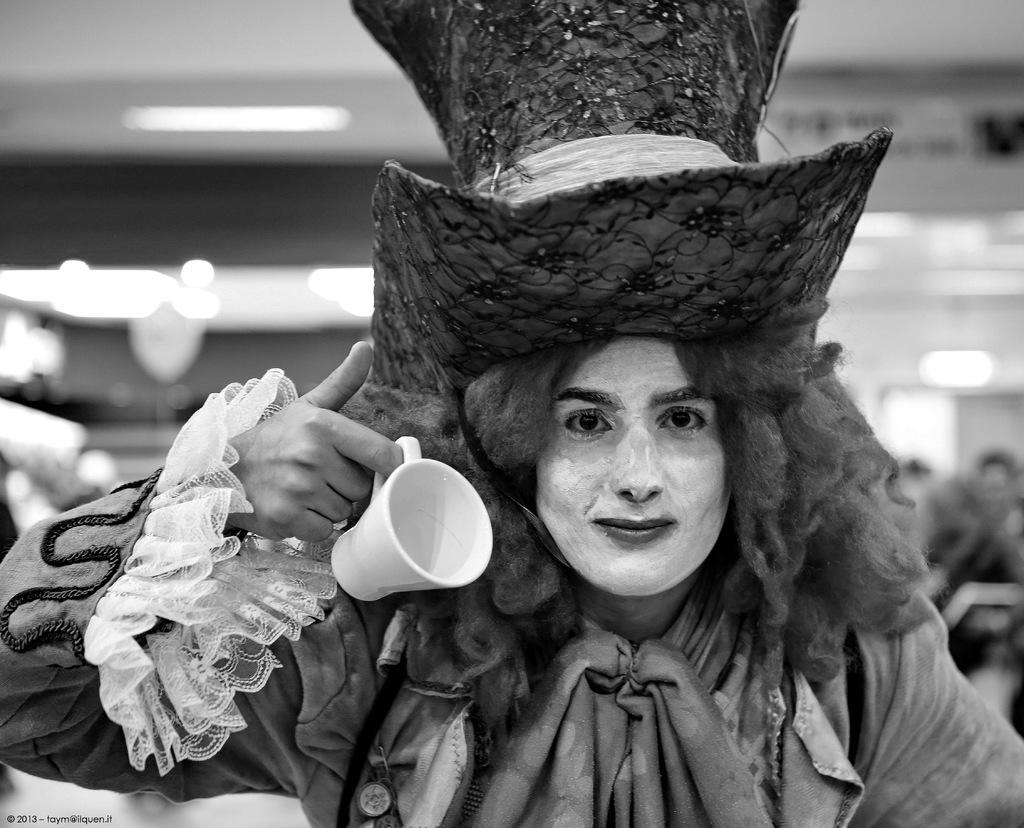What is the color scheme of the image? The image is black and white. How would you describe the background of the image? The background of the image is blurry. Can you identify any people in the image? Yes, there is a person in the image. What is the person wearing? The person is wearing a fancy dress. What object is the person holding in their hand? The person is holding a white-colored cup in their hand. What type of curtain can be seen in the image? There is no curtain present in the image. What type of business is being conducted in the image? The image does not depict any business activities. Can you tell me what color the crayon is that the person is holding in the image? There is no crayon present in the image; the person is holding a white-colored cup. 